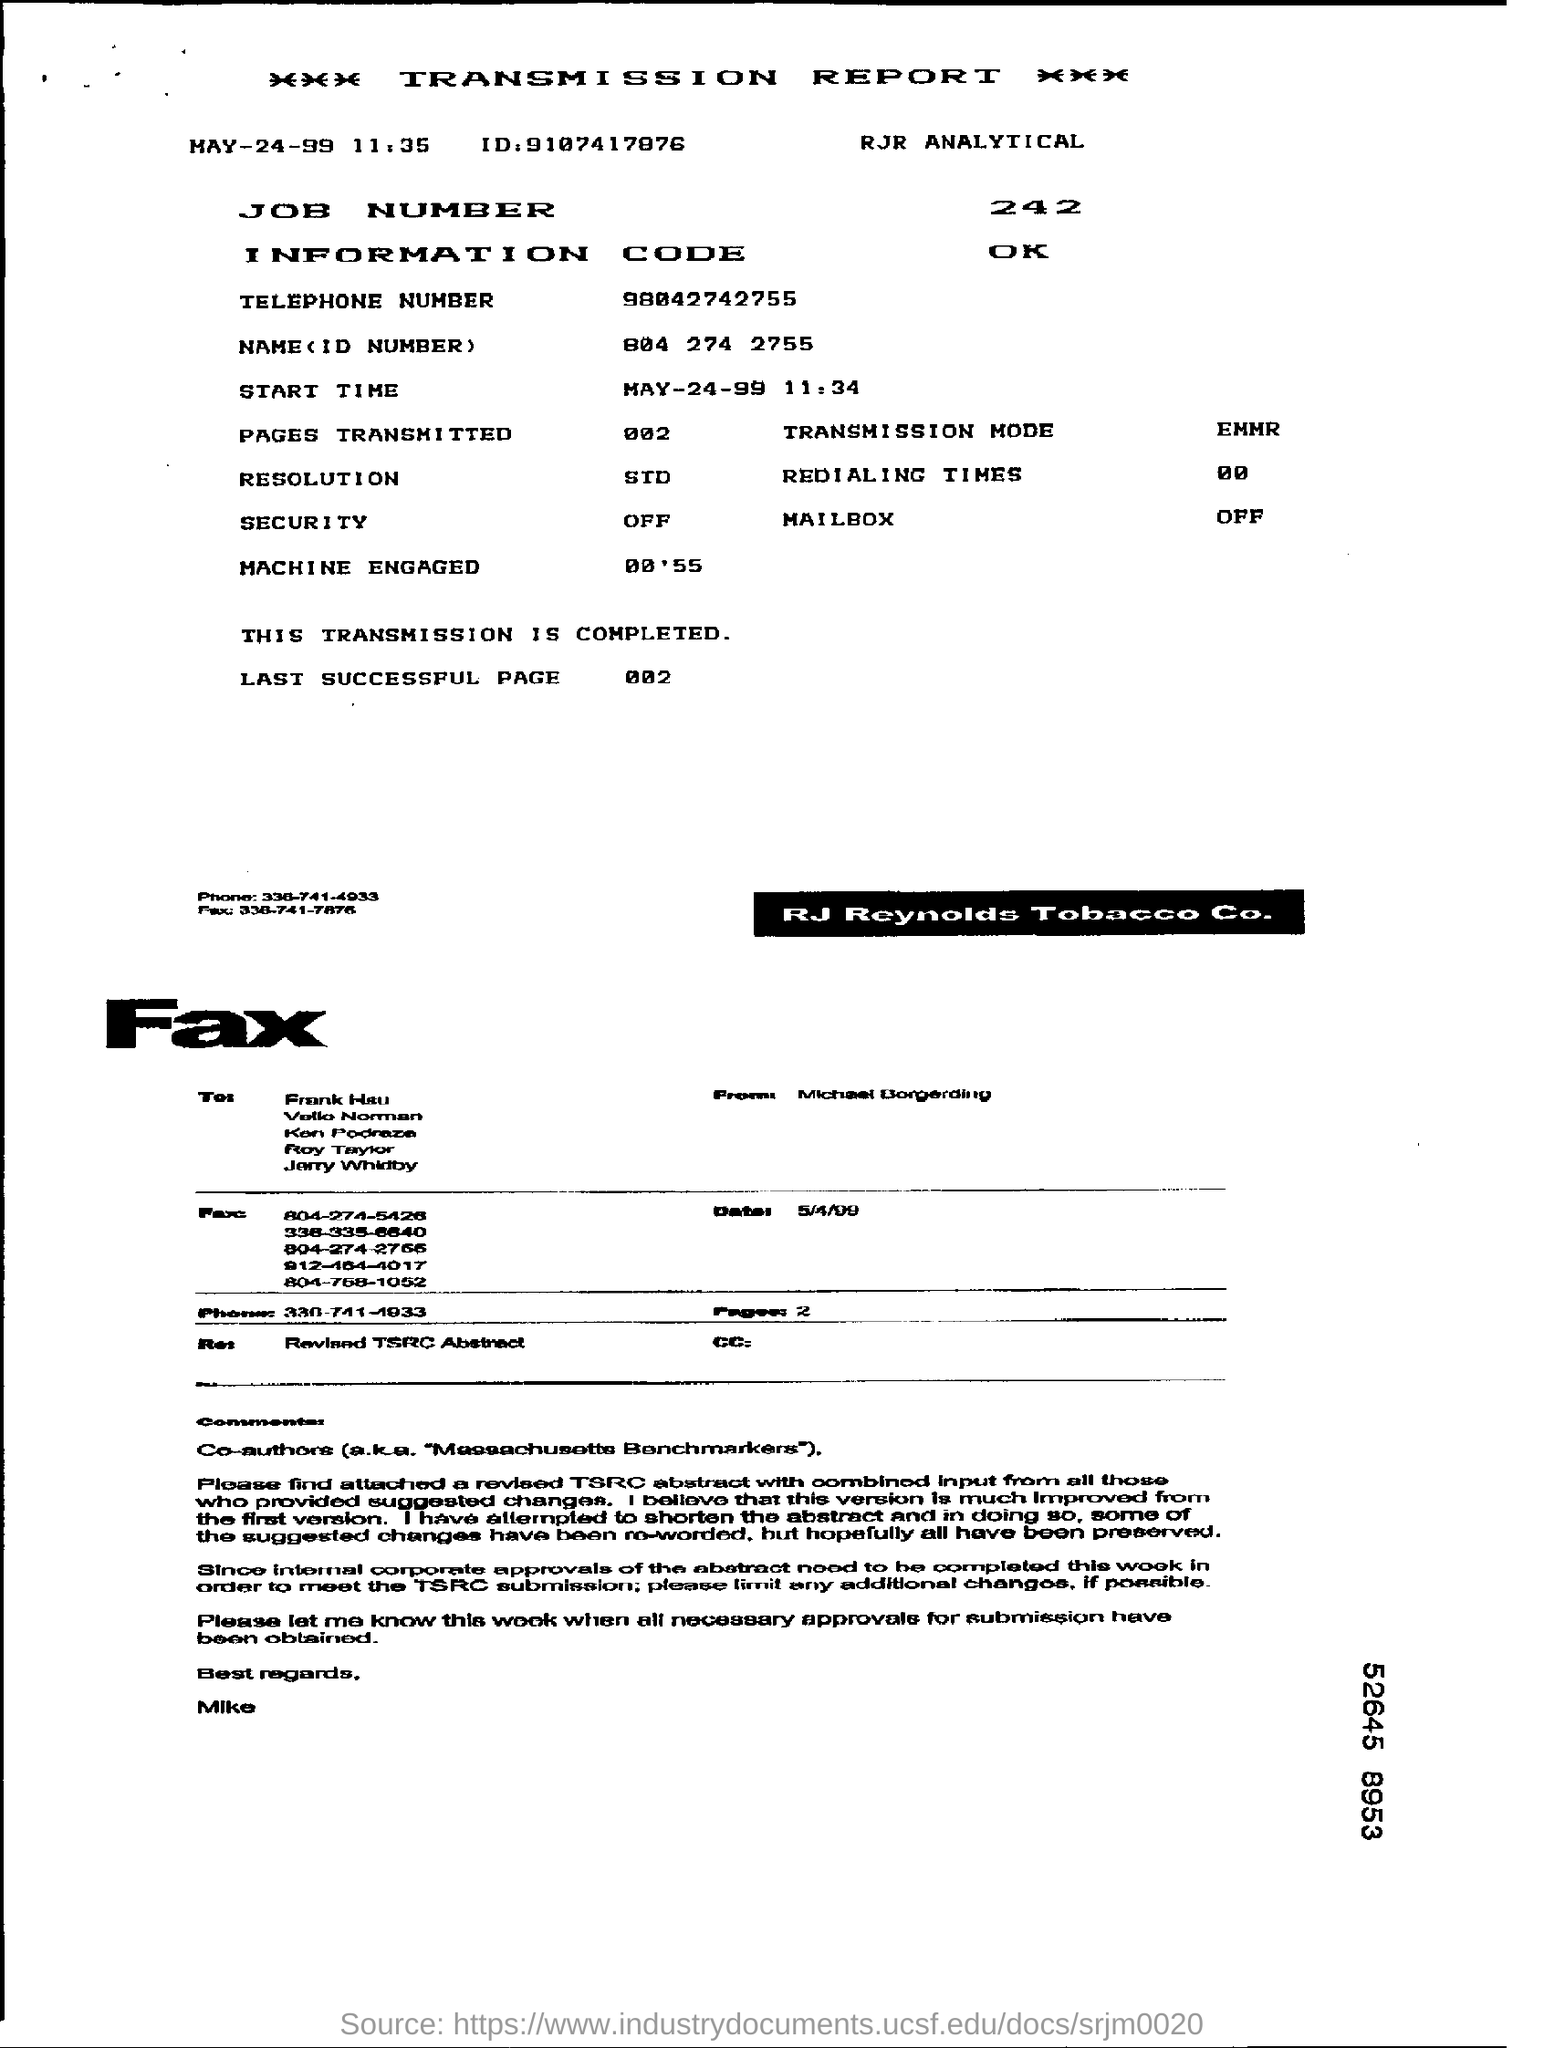What is the status of security?
Your response must be concise. Off. What is the Job number given in the transmission report?
Provide a succinct answer. 242. What is the last successful page?
Your answer should be very brief. 002. 